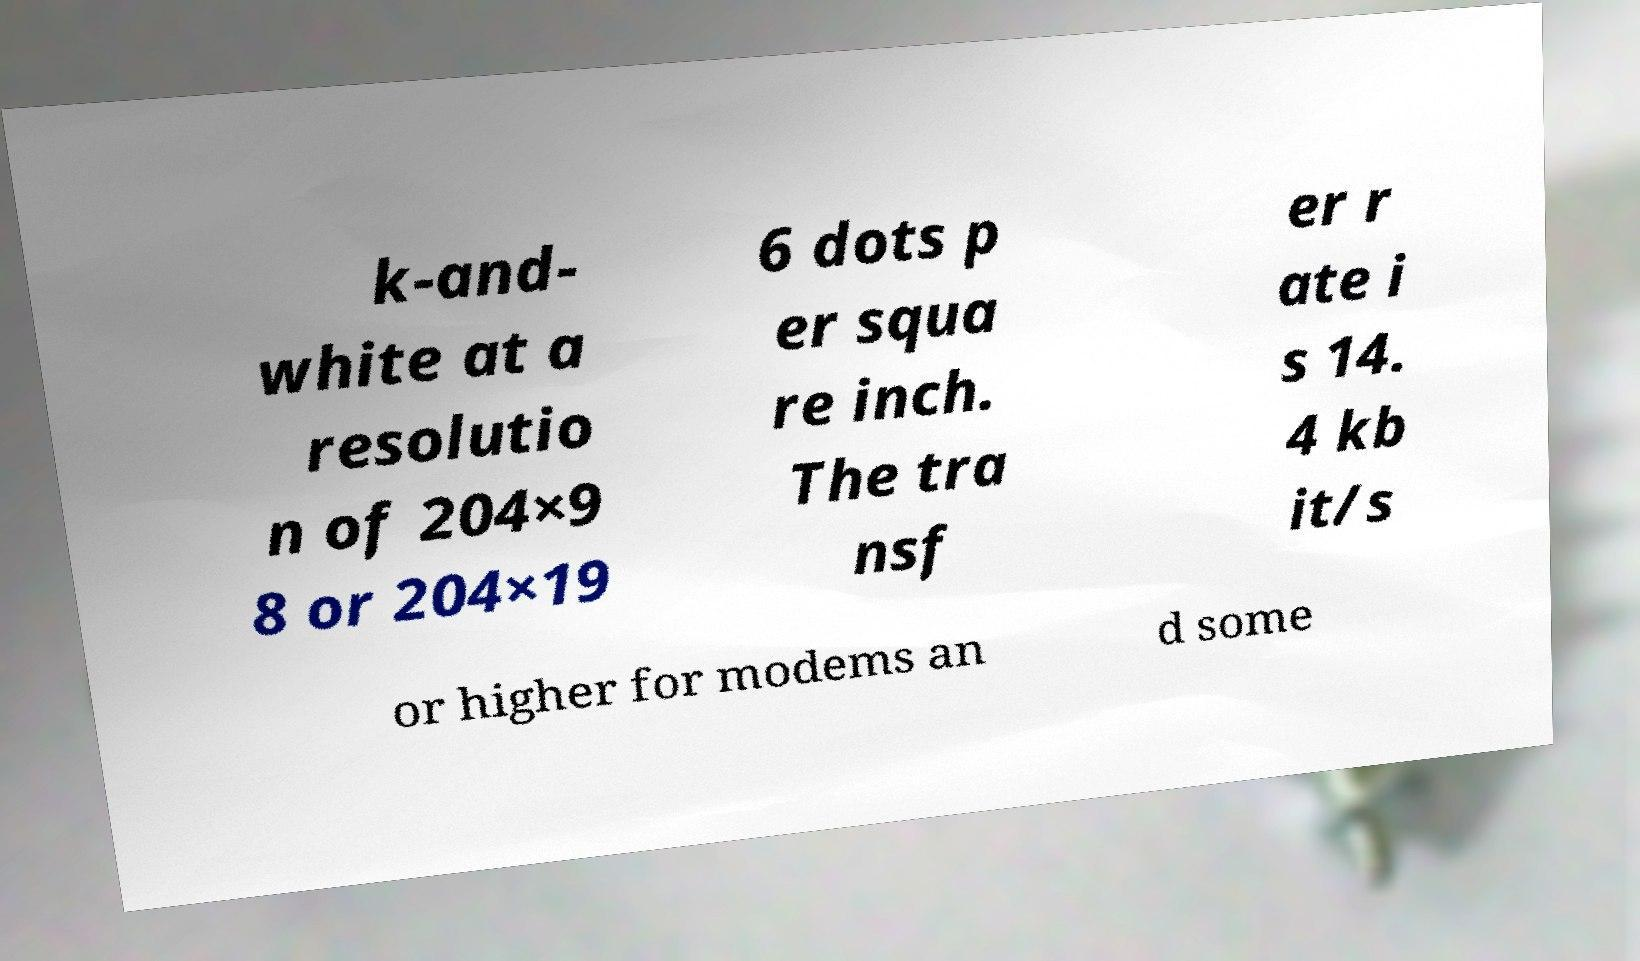For documentation purposes, I need the text within this image transcribed. Could you provide that? k-and- white at a resolutio n of 204×9 8 or 204×19 6 dots p er squa re inch. The tra nsf er r ate i s 14. 4 kb it/s or higher for modems an d some 